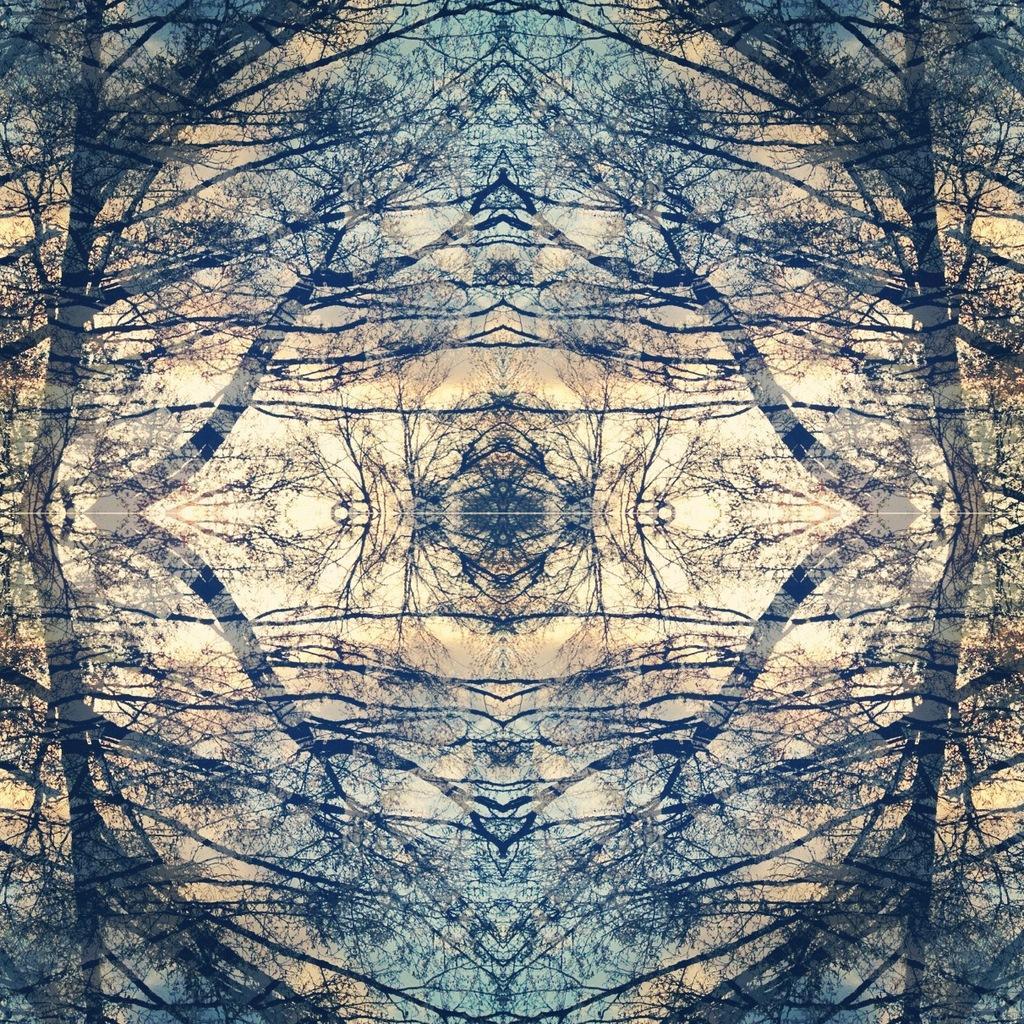Could you give a brief overview of what you see in this image? In this picture we can observe an art. On either sides we can observe a mirror image. We can observe blue and cream colors in this picture. This is an art of a tree. 